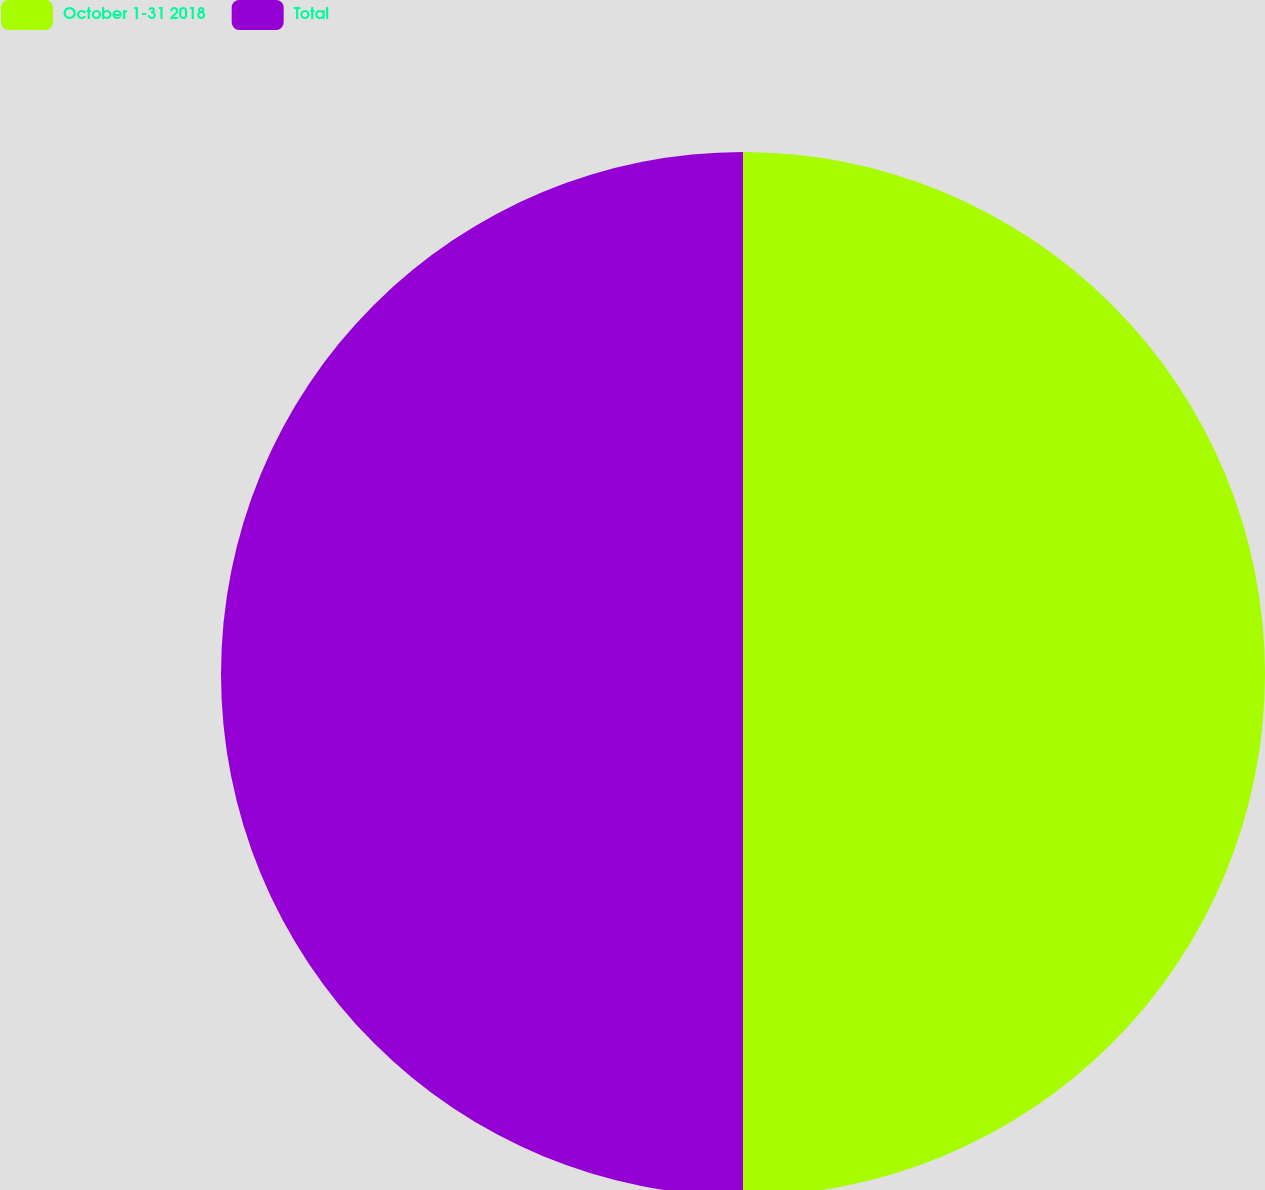Convert chart. <chart><loc_0><loc_0><loc_500><loc_500><pie_chart><fcel>October 1-31 2018<fcel>Total<nl><fcel>50.0%<fcel>50.0%<nl></chart> 